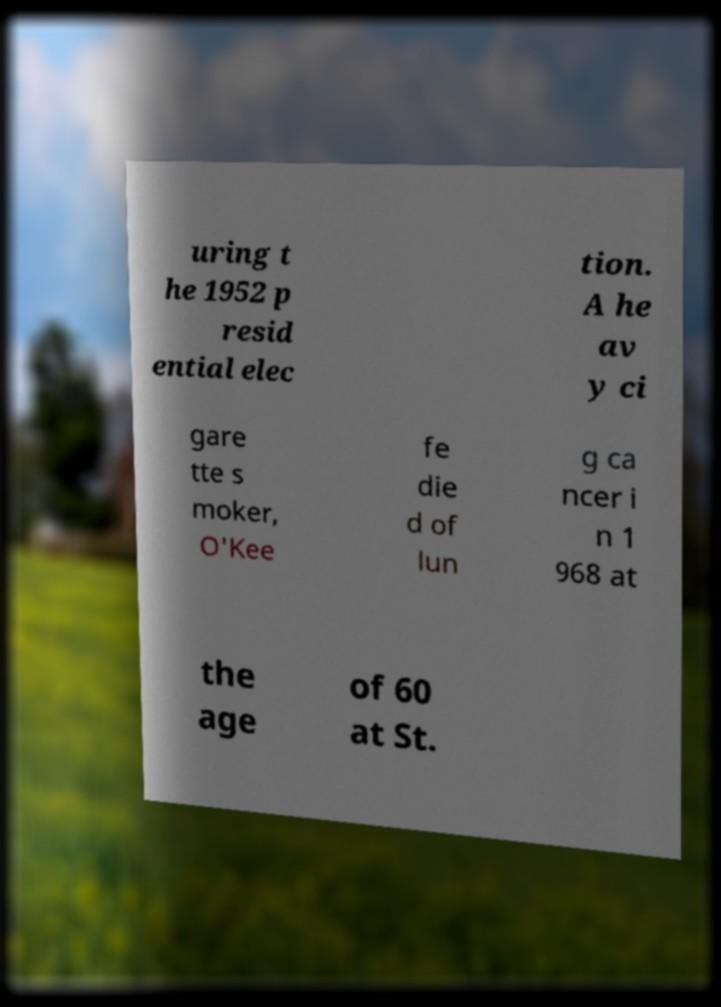I need the written content from this picture converted into text. Can you do that? uring t he 1952 p resid ential elec tion. A he av y ci gare tte s moker, O'Kee fe die d of lun g ca ncer i n 1 968 at the age of 60 at St. 